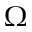Convert formula to latex. <formula><loc_0><loc_0><loc_500><loc_500>\Omega</formula> 